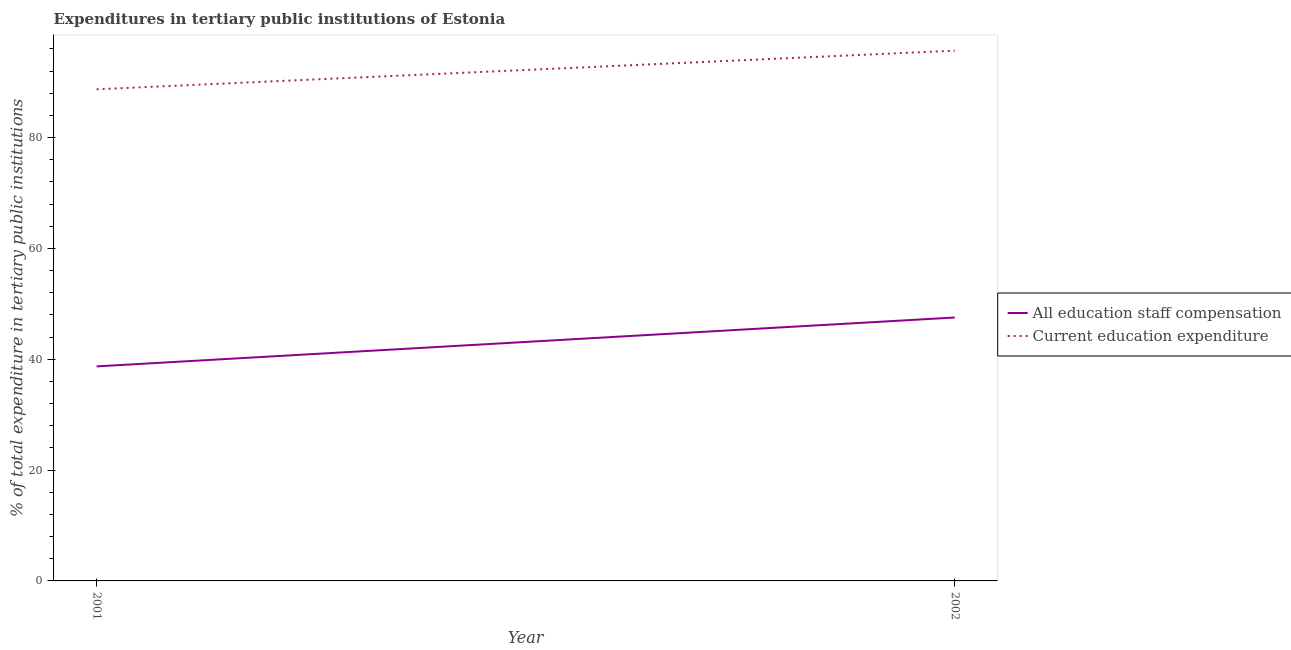How many different coloured lines are there?
Your answer should be very brief. 2. Does the line corresponding to expenditure in education intersect with the line corresponding to expenditure in staff compensation?
Your answer should be compact. No. Is the number of lines equal to the number of legend labels?
Make the answer very short. Yes. What is the expenditure in education in 2002?
Make the answer very short. 95.68. Across all years, what is the maximum expenditure in staff compensation?
Keep it short and to the point. 47.53. Across all years, what is the minimum expenditure in staff compensation?
Offer a very short reply. 38.71. In which year was the expenditure in staff compensation maximum?
Ensure brevity in your answer.  2002. In which year was the expenditure in staff compensation minimum?
Ensure brevity in your answer.  2001. What is the total expenditure in education in the graph?
Offer a terse response. 184.39. What is the difference between the expenditure in education in 2001 and that in 2002?
Give a very brief answer. -6.97. What is the difference between the expenditure in education in 2002 and the expenditure in staff compensation in 2001?
Ensure brevity in your answer.  56.97. What is the average expenditure in staff compensation per year?
Your answer should be very brief. 43.12. In the year 2001, what is the difference between the expenditure in education and expenditure in staff compensation?
Ensure brevity in your answer.  50. What is the ratio of the expenditure in education in 2001 to that in 2002?
Your response must be concise. 0.93. Is the expenditure in staff compensation in 2001 less than that in 2002?
Your response must be concise. Yes. In how many years, is the expenditure in education greater than the average expenditure in education taken over all years?
Your answer should be compact. 1. Does the expenditure in staff compensation monotonically increase over the years?
Your response must be concise. Yes. How many years are there in the graph?
Keep it short and to the point. 2. Does the graph contain any zero values?
Provide a short and direct response. No. Does the graph contain grids?
Provide a short and direct response. No. Where does the legend appear in the graph?
Offer a terse response. Center right. How are the legend labels stacked?
Give a very brief answer. Vertical. What is the title of the graph?
Offer a very short reply. Expenditures in tertiary public institutions of Estonia. What is the label or title of the Y-axis?
Offer a terse response. % of total expenditure in tertiary public institutions. What is the % of total expenditure in tertiary public institutions in All education staff compensation in 2001?
Keep it short and to the point. 38.71. What is the % of total expenditure in tertiary public institutions in Current education expenditure in 2001?
Your response must be concise. 88.71. What is the % of total expenditure in tertiary public institutions of All education staff compensation in 2002?
Give a very brief answer. 47.53. What is the % of total expenditure in tertiary public institutions of Current education expenditure in 2002?
Offer a terse response. 95.68. Across all years, what is the maximum % of total expenditure in tertiary public institutions of All education staff compensation?
Keep it short and to the point. 47.53. Across all years, what is the maximum % of total expenditure in tertiary public institutions of Current education expenditure?
Make the answer very short. 95.68. Across all years, what is the minimum % of total expenditure in tertiary public institutions of All education staff compensation?
Ensure brevity in your answer.  38.71. Across all years, what is the minimum % of total expenditure in tertiary public institutions in Current education expenditure?
Provide a succinct answer. 88.71. What is the total % of total expenditure in tertiary public institutions of All education staff compensation in the graph?
Offer a very short reply. 86.24. What is the total % of total expenditure in tertiary public institutions in Current education expenditure in the graph?
Your response must be concise. 184.39. What is the difference between the % of total expenditure in tertiary public institutions in All education staff compensation in 2001 and that in 2002?
Keep it short and to the point. -8.82. What is the difference between the % of total expenditure in tertiary public institutions of Current education expenditure in 2001 and that in 2002?
Offer a terse response. -6.97. What is the difference between the % of total expenditure in tertiary public institutions of All education staff compensation in 2001 and the % of total expenditure in tertiary public institutions of Current education expenditure in 2002?
Offer a terse response. -56.97. What is the average % of total expenditure in tertiary public institutions of All education staff compensation per year?
Offer a very short reply. 43.12. What is the average % of total expenditure in tertiary public institutions of Current education expenditure per year?
Ensure brevity in your answer.  92.19. In the year 2001, what is the difference between the % of total expenditure in tertiary public institutions in All education staff compensation and % of total expenditure in tertiary public institutions in Current education expenditure?
Offer a terse response. -50. In the year 2002, what is the difference between the % of total expenditure in tertiary public institutions of All education staff compensation and % of total expenditure in tertiary public institutions of Current education expenditure?
Your response must be concise. -48.15. What is the ratio of the % of total expenditure in tertiary public institutions of All education staff compensation in 2001 to that in 2002?
Offer a terse response. 0.81. What is the ratio of the % of total expenditure in tertiary public institutions of Current education expenditure in 2001 to that in 2002?
Your answer should be compact. 0.93. What is the difference between the highest and the second highest % of total expenditure in tertiary public institutions in All education staff compensation?
Your answer should be compact. 8.82. What is the difference between the highest and the second highest % of total expenditure in tertiary public institutions in Current education expenditure?
Ensure brevity in your answer.  6.97. What is the difference between the highest and the lowest % of total expenditure in tertiary public institutions in All education staff compensation?
Offer a very short reply. 8.82. What is the difference between the highest and the lowest % of total expenditure in tertiary public institutions of Current education expenditure?
Your answer should be very brief. 6.97. 